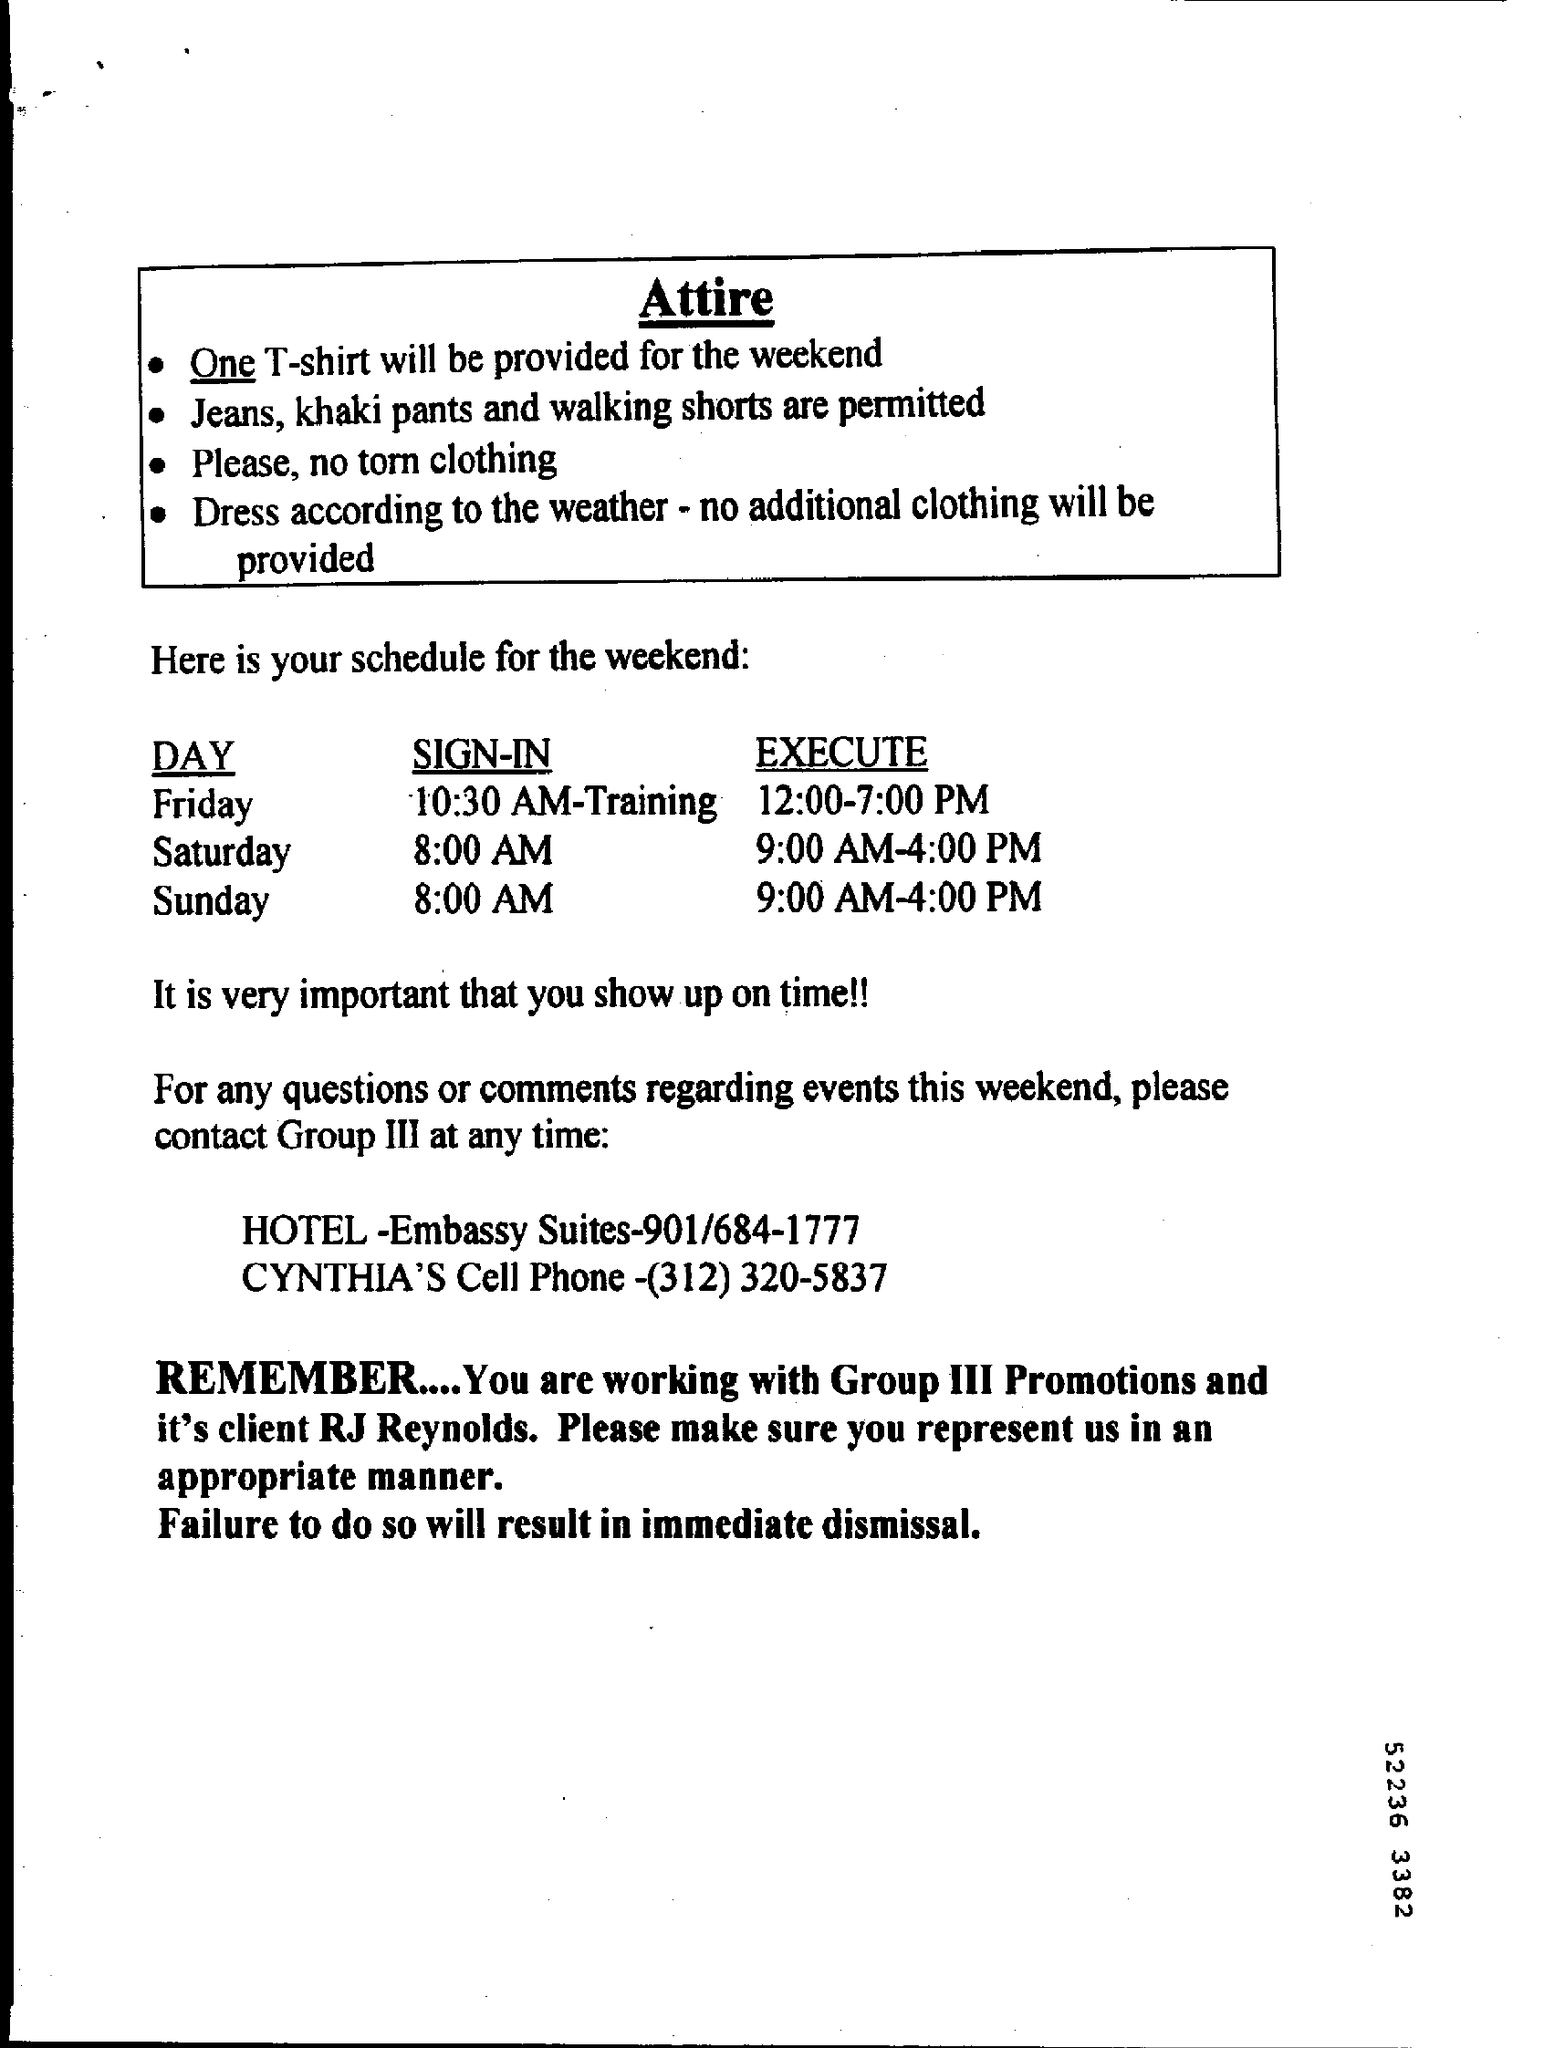Outline some significant characteristics in this image. We will provide one t-shirt for the entire weekend. The training will take place on Friday at 10:30 AM. The client of group III promotions is RJ REYNOLDS. The cell phone number of Cynthia is (312) 320-5837. 